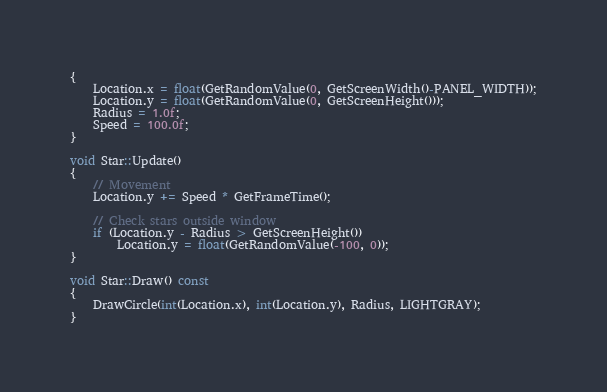Convert code to text. <code><loc_0><loc_0><loc_500><loc_500><_C++_>{
	Location.x = float(GetRandomValue(0, GetScreenWidth()-PANEL_WIDTH));
	Location.y = float(GetRandomValue(0, GetScreenHeight()));
	Radius = 1.0f;
	Speed = 100.0f;
}

void Star::Update()
{
	// Movement
	Location.y += Speed * GetFrameTime();

	// Check stars outside window
	if (Location.y - Radius > GetScreenHeight())
		Location.y = float(GetRandomValue(-100, 0));
}

void Star::Draw() const
{
	DrawCircle(int(Location.x), int(Location.y), Radius, LIGHTGRAY);
}
</code> 